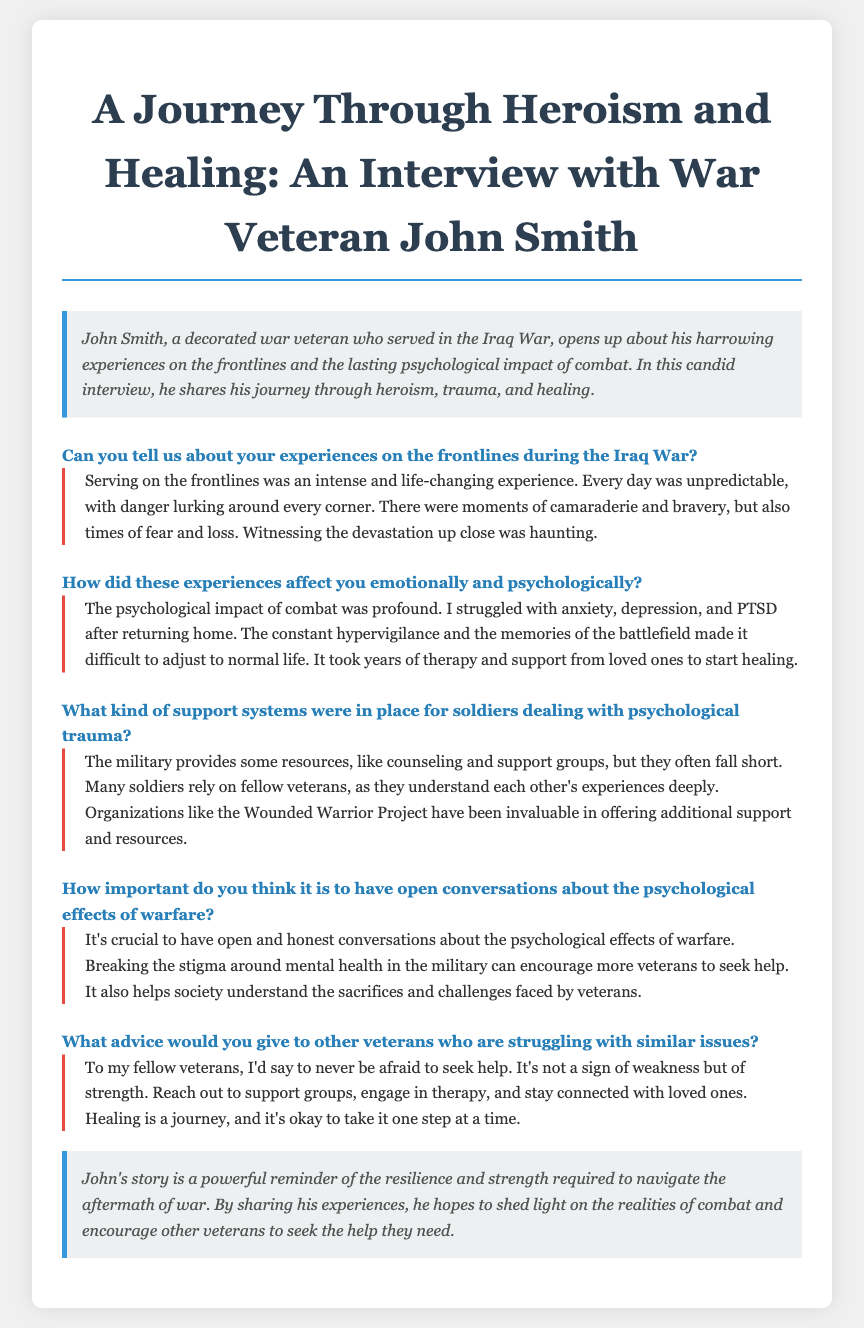What is the title of the interview transcript? The title is "A Journey Through Heroism and Healing: An Interview with War Veteran John Smith."
Answer: A Journey Through Heroism and Healing: An Interview with War Veteran John Smith Who is the interviewee in the document? The interviewee is John Smith, a decorated war veteran.
Answer: John Smith What war did John Smith serve in? John Smith served in the Iraq War.
Answer: Iraq War What psychological condition did John Smith mention struggling with? He mentioned struggling with PTSD after returning home.
Answer: PTSD How does John Smith describe the relationship between soldiers regarding psychological trauma? He notes that many soldiers rely on fellow veterans who understand each other's experiences deeply.
Answer: Fellow veterans What does John Smith believe is crucial for veterans? He believes it's crucial to have open and honest conversations about the psychological effects of warfare.
Answer: Open conversations What organization does John Smith mention for additional support? He mentions the Wounded Warrior Project.
Answer: Wounded Warrior Project What advice does John Smith give to fellow veterans? He advises them to never be afraid to seek help.
Answer: Seek help What aspect of John Smith's story is emphasized in the closing? The closing emphasizes the resilience and strength required to navigate the aftermath of war.
Answer: Resilience and strength 